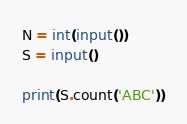<code> <loc_0><loc_0><loc_500><loc_500><_Python_>N = int(input())
S = input()

print(S.count('ABC'))</code> 